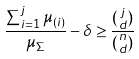Convert formula to latex. <formula><loc_0><loc_0><loc_500><loc_500>\frac { \sum _ { i = 1 } ^ { j } \mu _ { ( i ) } } { \mu _ { \Sigma } } - \delta \geq \frac { \binom { j } { d } } { \binom { n } { d } }</formula> 